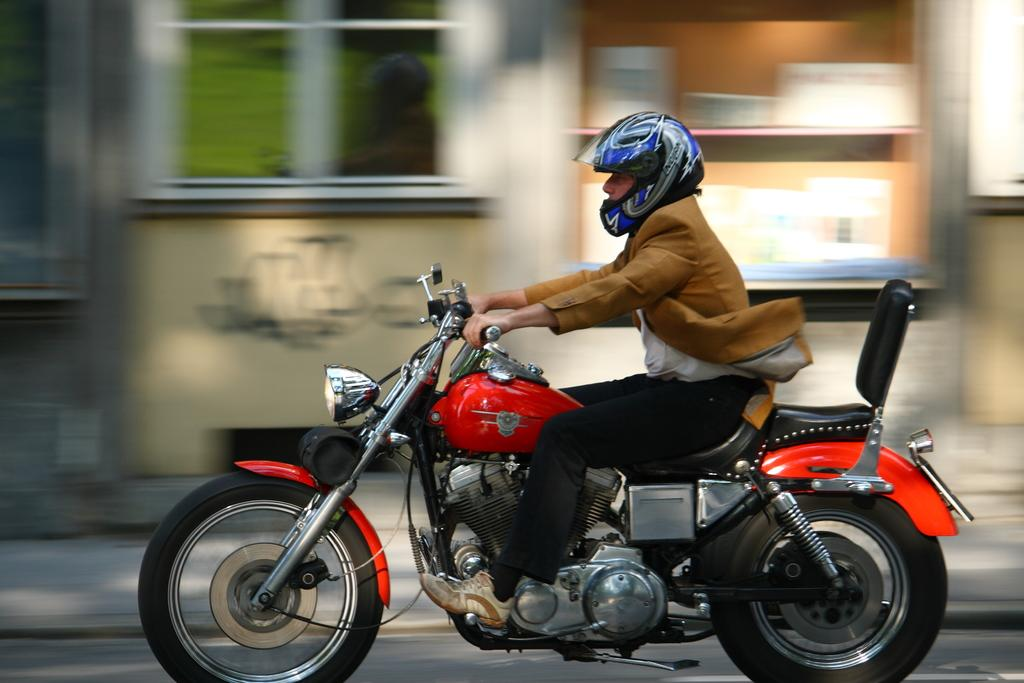Who is present in the image? There is a person in the image. What is the person doing in the image? The person is riding a bike. Where is the bike located in the image? The bike is on a road. What type of cactus can be seen in the image? There is no cactus present in the image; it features a person riding a bike on a road. 